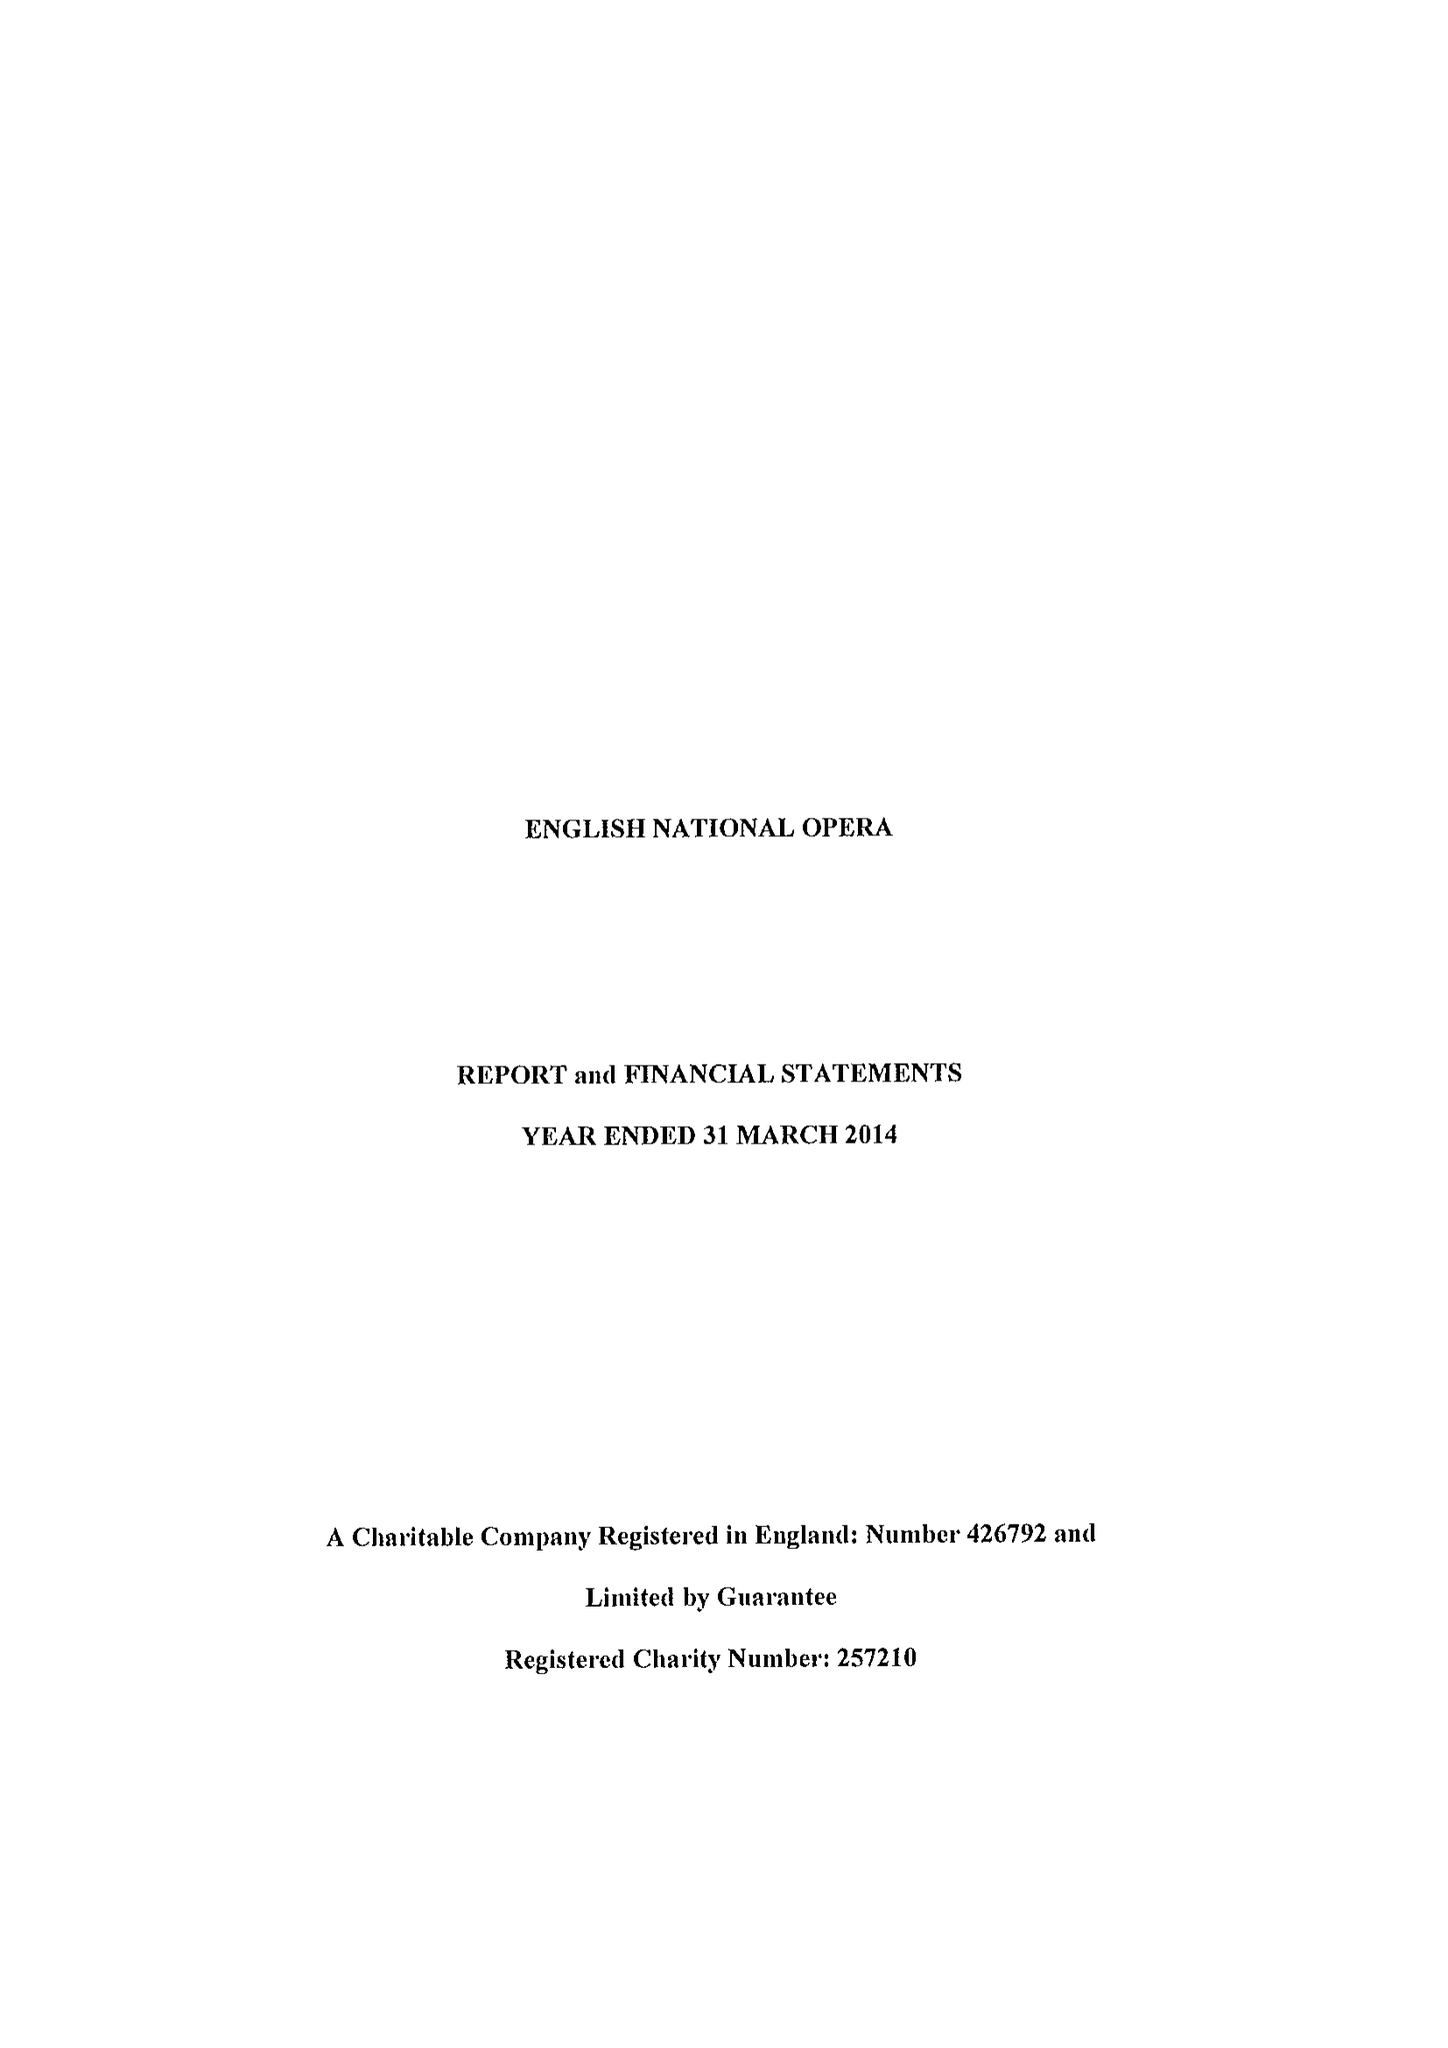What is the value for the spending_annually_in_british_pounds?
Answer the question using a single word or phrase. 36703000.00 